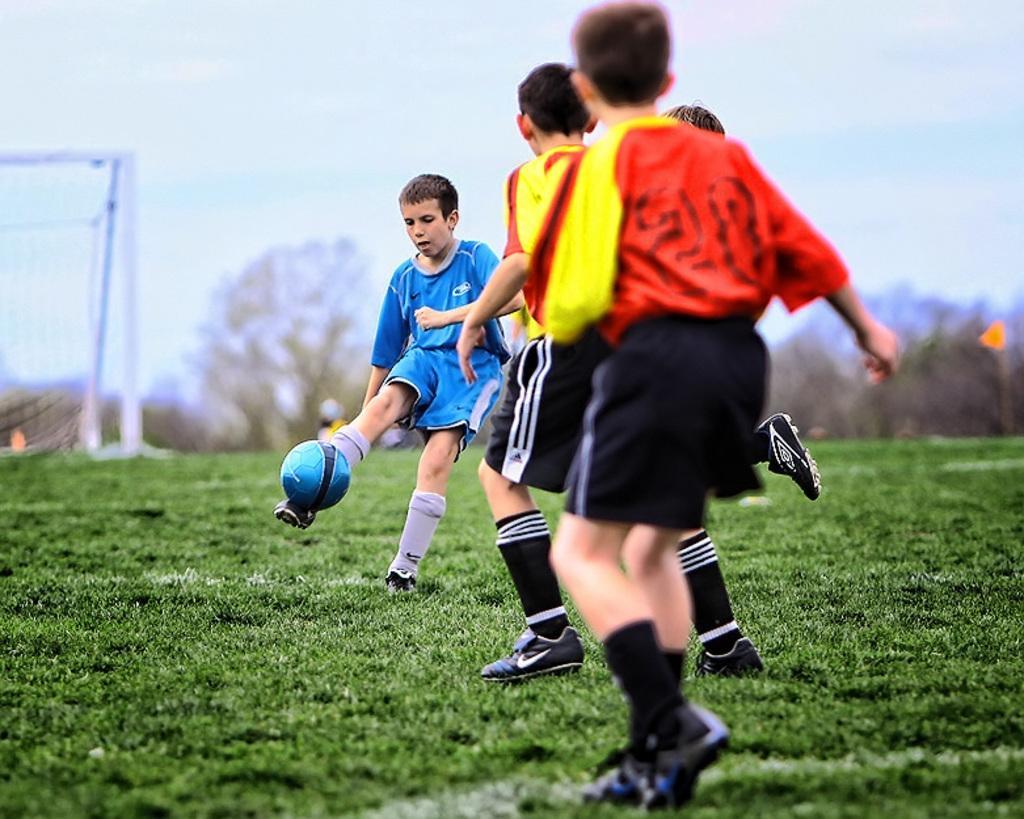Could you give a brief overview of what you see in this image? In this picture we can see some persons are playing football. This is grass and there is a mesh. On the background there are trees and this is sky. 